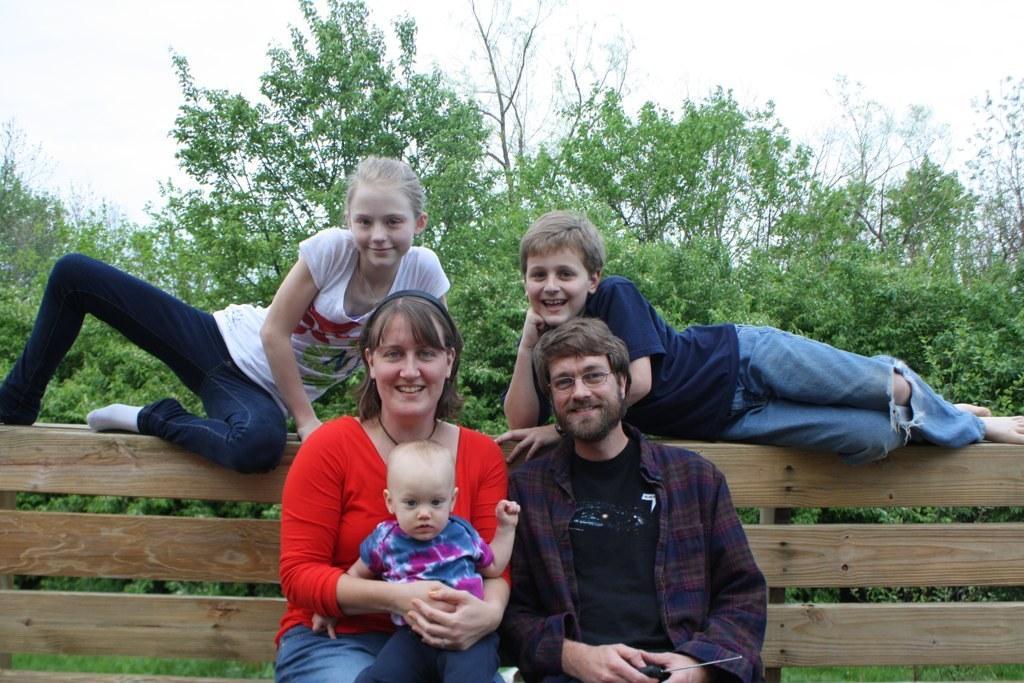Describe this image in one or two sentences. In the picture we can see a man and a woman sitting on the bench and leaning to the wooden plank and a woman is holding a baby and on the wooden plank we can see a boy and a girl are laid and behind them we can see many trees and a part of the sky. 